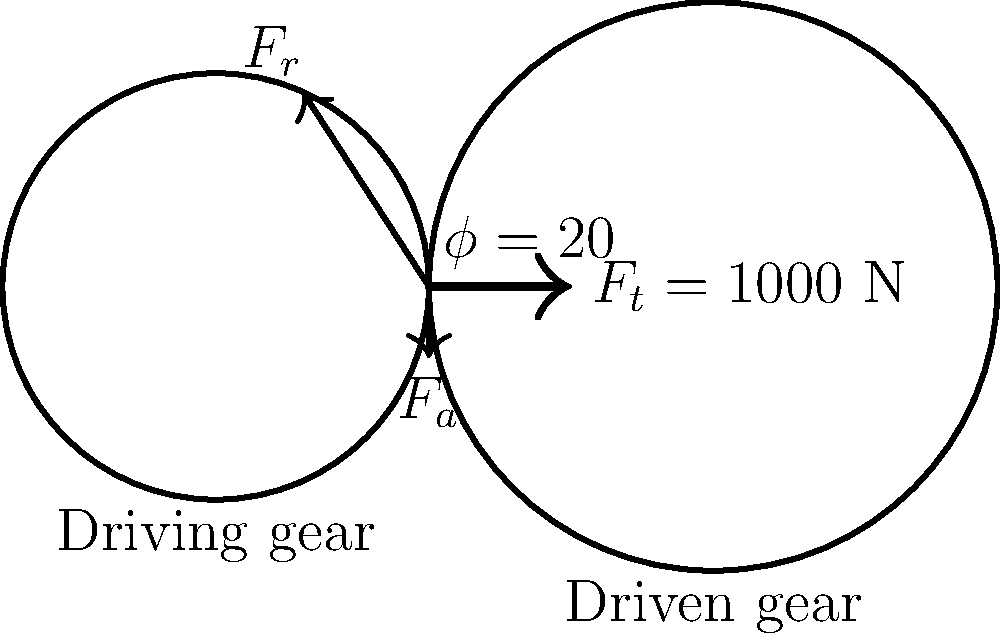A spur gear system consists of a driving gear and a driven gear. The tangential force $F_t$ applied to the gear tooth is 1000 N, and the pressure angle $\phi$ is 20°. Calculate the radial force $F_r$ and the axial force $F_a$ acting on the gear tooth. How does the pressure angle affect the distribution of forces in the gear system? To solve this problem, we'll follow these steps:

1) In a spur gear system, there are three components of force acting on a gear tooth:
   - Tangential force ($F_t$)
   - Radial force ($F_r$)
   - Axial force ($F_a$)

2) The tangential force $F_t$ is given as 1000 N, and the pressure angle $\phi$ is 20°.

3) To calculate the radial force $F_r$:
   $$F_r = F_t \tan(\phi)$$
   $$F_r = 1000 \tan(20°) = 1000 \cdot 0.3640 = 364.0 \text{ N}$$

4) In a spur gear system, there is no axial force, so $F_a = 0 \text{ N}$.

5) The pressure angle affects the force distribution as follows:
   - A larger pressure angle increases the radial force component.
   - This can lead to increased separation force between the gears, potentially requiring stronger bearings.
   - However, larger pressure angles can also increase the contact ratio, potentially improving load distribution and reducing noise.
   - Smaller pressure angles result in lower radial forces but may lead to undercutting of gear teeth, especially in gears with few teeth.

6) The choice of pressure angle is a trade-off between these factors, with 20° being a common compromise in many applications.
Answer: $F_r = 364.0 \text{ N}$, $F_a = 0 \text{ N}$. Larger pressure angles increase radial forces, affecting bearing loads and gear contact. 